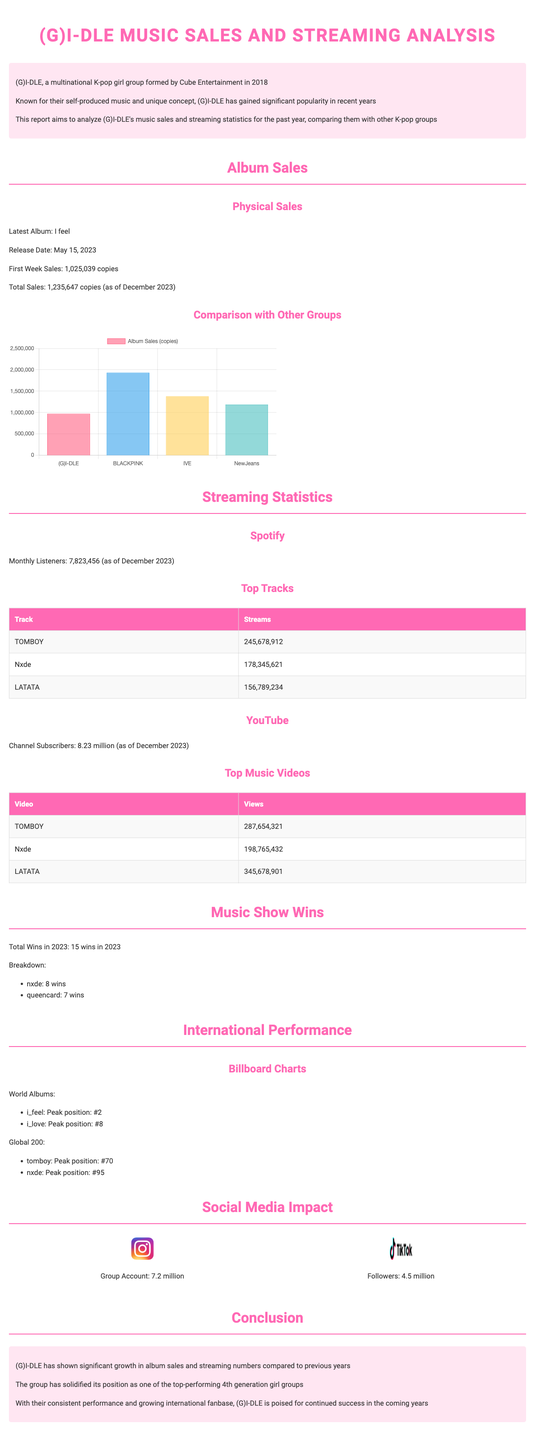What is the name of (G)I-DLE's latest album? The latest album is specified in the document as the most recent release by (G)I-DLE.
Answer: I feel When was the album "I love" released? The document provides the release date for the previous album, which is important for fans to know.
Answer: October 17, 2022 What was the first-week sales for "I feel"? The first-week sales figures are included to highlight the album's initial performance.
Answer: 1,025,039 copies How many total wins did (G)I-DLE achieve in 2023? The report summarizes the group's achievements, particularly their wins on music shows, which is a significant indicator of popularity.
Answer: 15 wins What is (G)I-DLE's peak position on the Billboard World Albums chart for "I feel"? This position indicates the international success of the album in major music charts.
Answer: #2 How many monthly listeners does (G)I-DLE have on Spotify? The number of monthly listeners is an important metric for evaluating an artist's current popularity on streaming platforms.
Answer: 7,823,456 How many copies did BLACKPINK's album "BORN PINK" sell? The document includes a comparison of album sales among different K-pop groups, highlighting BLACKPINK's performance.
Answer: 2,254,031 copies Which member has the most Instagram followers? The document provides details about the group's social media impact, specifically noting the most followed member.
Answer: Miyeon What is the view count for the music video "TOMBOY"? This specific view count reflects the popularity of (G)I-DLE’s music videos on platforms like YouTube.
Answer: 287,654,321 